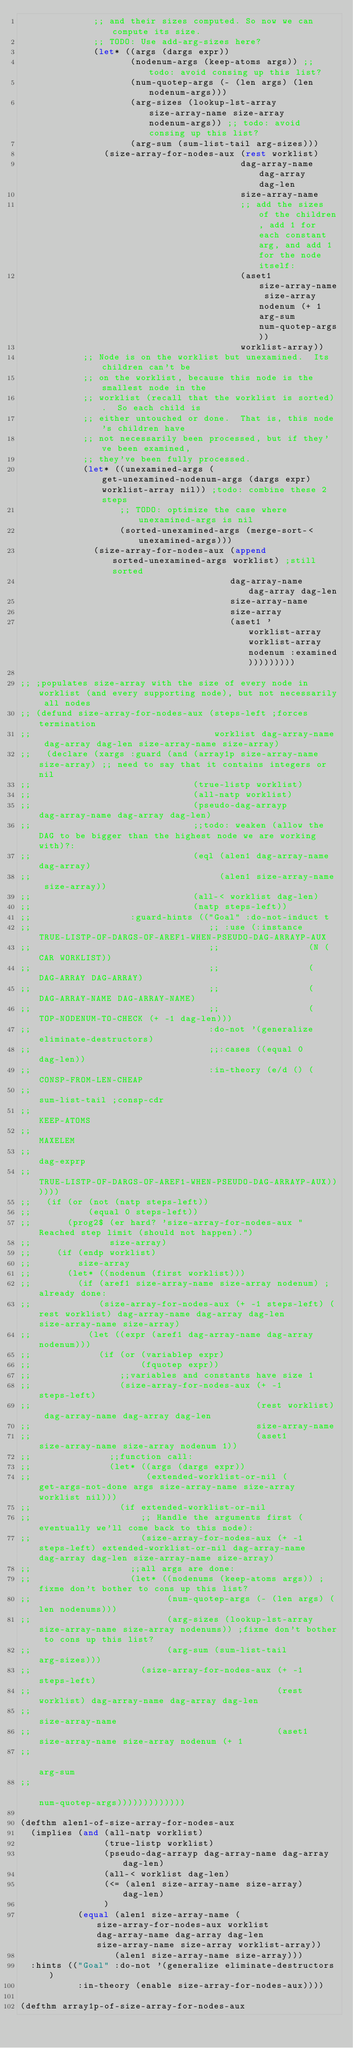Convert code to text. <code><loc_0><loc_0><loc_500><loc_500><_Lisp_>              ;; and their sizes computed. So now we can compute its size.
              ;; TODO: Use add-arg-sizes here?
              (let* ((args (dargs expr))
                     (nodenum-args (keep-atoms args)) ;; todo: avoid consing up this list?
                     (num-quotep-args (- (len args) (len nodenum-args)))
                     (arg-sizes (lookup-lst-array size-array-name size-array nodenum-args)) ;; todo: avoid consing up this list?
                     (arg-sum (sum-list-tail arg-sizes)))
                (size-array-for-nodes-aux (rest worklist)
                                          dag-array-name dag-array dag-len
                                          size-array-name
                                          ;; add the sizes of the children, add 1 for each constant arg, and add 1 for the node itself:
                                          (aset1 size-array-name size-array nodenum (+ 1 arg-sum num-quotep-args))
                                          worklist-array))
            ;; Node is on the worklist but unexamined.  Its children can't be
            ;; on the worklist, because this node is the smallest node in the
            ;; worklist (recall that the worklist is sorted).  So each child is
            ;; either untouched or done.  That is, this node's children have
            ;; not necessarily been processed, but if they've been examined,
            ;; they've been fully processed.
            (let* ((unexamined-args (get-unexamined-nodenum-args (dargs expr) worklist-array nil)) ;todo: combine these 2 steps
                   ;; TODO: optimize the case where unexamined-args is nil
                   (sorted-unexamined-args (merge-sort-< unexamined-args)))
              (size-array-for-nodes-aux (append sorted-unexamined-args worklist) ;still sorted
                                        dag-array-name dag-array dag-len
                                        size-array-name
                                        size-array
                                        (aset1 'worklist-array worklist-array nodenum :examined)))))))))

;; ;populates size-array with the size of every node in worklist (and every supporting node), but not necessarily all nodes
;; (defund size-array-for-nodes-aux (steps-left ;forces termination
;;                                   worklist dag-array-name dag-array dag-len size-array-name size-array)
;;   (declare (xargs :guard (and (array1p size-array-name size-array) ;; need to say that it contains integers or nil
;;                               (true-listp worklist)
;;                               (all-natp worklist)
;;                               (pseudo-dag-arrayp dag-array-name dag-array dag-len)
;;                               ;;todo: weaken (allow the DAG to be bigger than the highest node we are working with)?:
;;                               (eql (alen1 dag-array-name dag-array)
;;                                    (alen1 size-array-name size-array))
;;                               (all-< worklist dag-len)
;;                               (natp steps-left))
;;                   :guard-hints (("Goal" :do-not-induct t
;;                                  ;; :use (:instance TRUE-LISTP-OF-DARGS-OF-AREF1-WHEN-PSEUDO-DAG-ARRAYP-AUX
;;                                  ;;                 (N (CAR WORKLIST))
;;                                  ;;                 (DAG-ARRAY DAG-ARRAY)
;;                                  ;;                 (DAG-ARRAY-NAME DAG-ARRAY-NAME)
;;                                  ;;                 (TOP-NODENUM-TO-CHECK (+ -1 dag-len)))
;;                                  :do-not '(generalize eliminate-destructors)
;;                                  ;;:cases ((equal 0 dag-len))
;;                                  :in-theory (e/d () (CONSP-FROM-LEN-CHEAP
;;                                                      sum-list-tail ;consp-cdr
;;                                                      KEEP-ATOMS
;;                                                      MAXELEM
;;                                                      dag-exprp
;;                                                      TRUE-LISTP-OF-DARGS-OF-AREF1-WHEN-PSEUDO-DAG-ARRAYP-AUX))))))
;;   (if (or (not (natp steps-left))
;;           (equal 0 steps-left))
;;       (prog2$ (er hard? 'size-array-for-nodes-aux "Reached step limit (should not happen).")
;;               size-array)
;;     (if (endp worklist)
;;         size-array
;;       (let* ((nodenum (first worklist)))
;;         (if (aref1 size-array-name size-array nodenum) ;already done:
;;             (size-array-for-nodes-aux (+ -1 steps-left) (rest worklist) dag-array-name dag-array dag-len size-array-name size-array)
;;           (let ((expr (aref1 dag-array-name dag-array nodenum)))
;;             (if (or (variablep expr)
;;                     (fquotep expr))
;;                 ;;variables and constants have size 1
;;                 (size-array-for-nodes-aux (+ -1 steps-left)
;;                                           (rest worklist) dag-array-name dag-array dag-len
;;                                           size-array-name
;;                                           (aset1 size-array-name size-array nodenum 1))
;;               ;;function call:
;;               (let* ((args (dargs expr))
;;                      (extended-worklist-or-nil (get-args-not-done args size-array-name size-array worklist nil)))
;;                 (if extended-worklist-or-nil
;;                     ;; Handle the arguments first (eventually we'll come back to this node):
;;                     (size-array-for-nodes-aux (+ -1 steps-left) extended-worklist-or-nil dag-array-name dag-array dag-len size-array-name size-array)
;;                   ;;all args are done:
;;                   (let* ((nodenums (keep-atoms args)) ;fixme don't bother to cons up this list?
;;                          (num-quotep-args (- (len args) (len nodenums)))
;;                          (arg-sizes (lookup-lst-array size-array-name size-array nodenums)) ;fixme don't bother to cons up this list?
;;                          (arg-sum (sum-list-tail arg-sizes)))
;;                     (size-array-for-nodes-aux (+ -1 steps-left)
;;                                               (rest worklist) dag-array-name dag-array dag-len
;;                                               size-array-name
;;                                               (aset1 size-array-name size-array nodenum (+ 1
;;                                                                                            arg-sum
;;                                                                                            num-quotep-args)))))))))))))

(defthm alen1-of-size-array-for-nodes-aux
  (implies (and (all-natp worklist)
                (true-listp worklist)
                (pseudo-dag-arrayp dag-array-name dag-array dag-len)
                (all-< worklist dag-len)
                (<= (alen1 size-array-name size-array) dag-len)
                )
           (equal (alen1 size-array-name (size-array-for-nodes-aux worklist dag-array-name dag-array dag-len size-array-name size-array worklist-array))
                  (alen1 size-array-name size-array)))
  :hints (("Goal" :do-not '(generalize eliminate-destructors)
           :in-theory (enable size-array-for-nodes-aux))))

(defthm array1p-of-size-array-for-nodes-aux</code> 